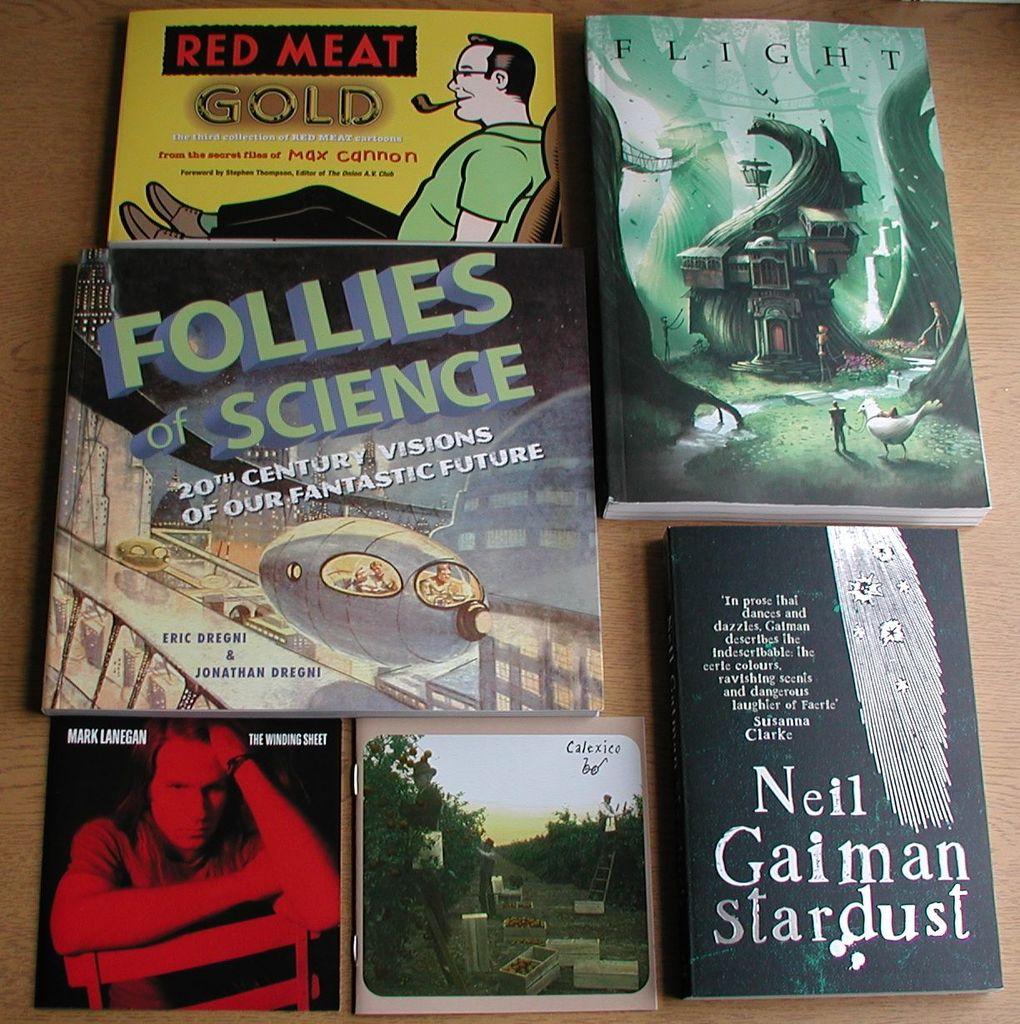Who wrote the bottom right book?
Provide a succinct answer. Neil gaiman. 